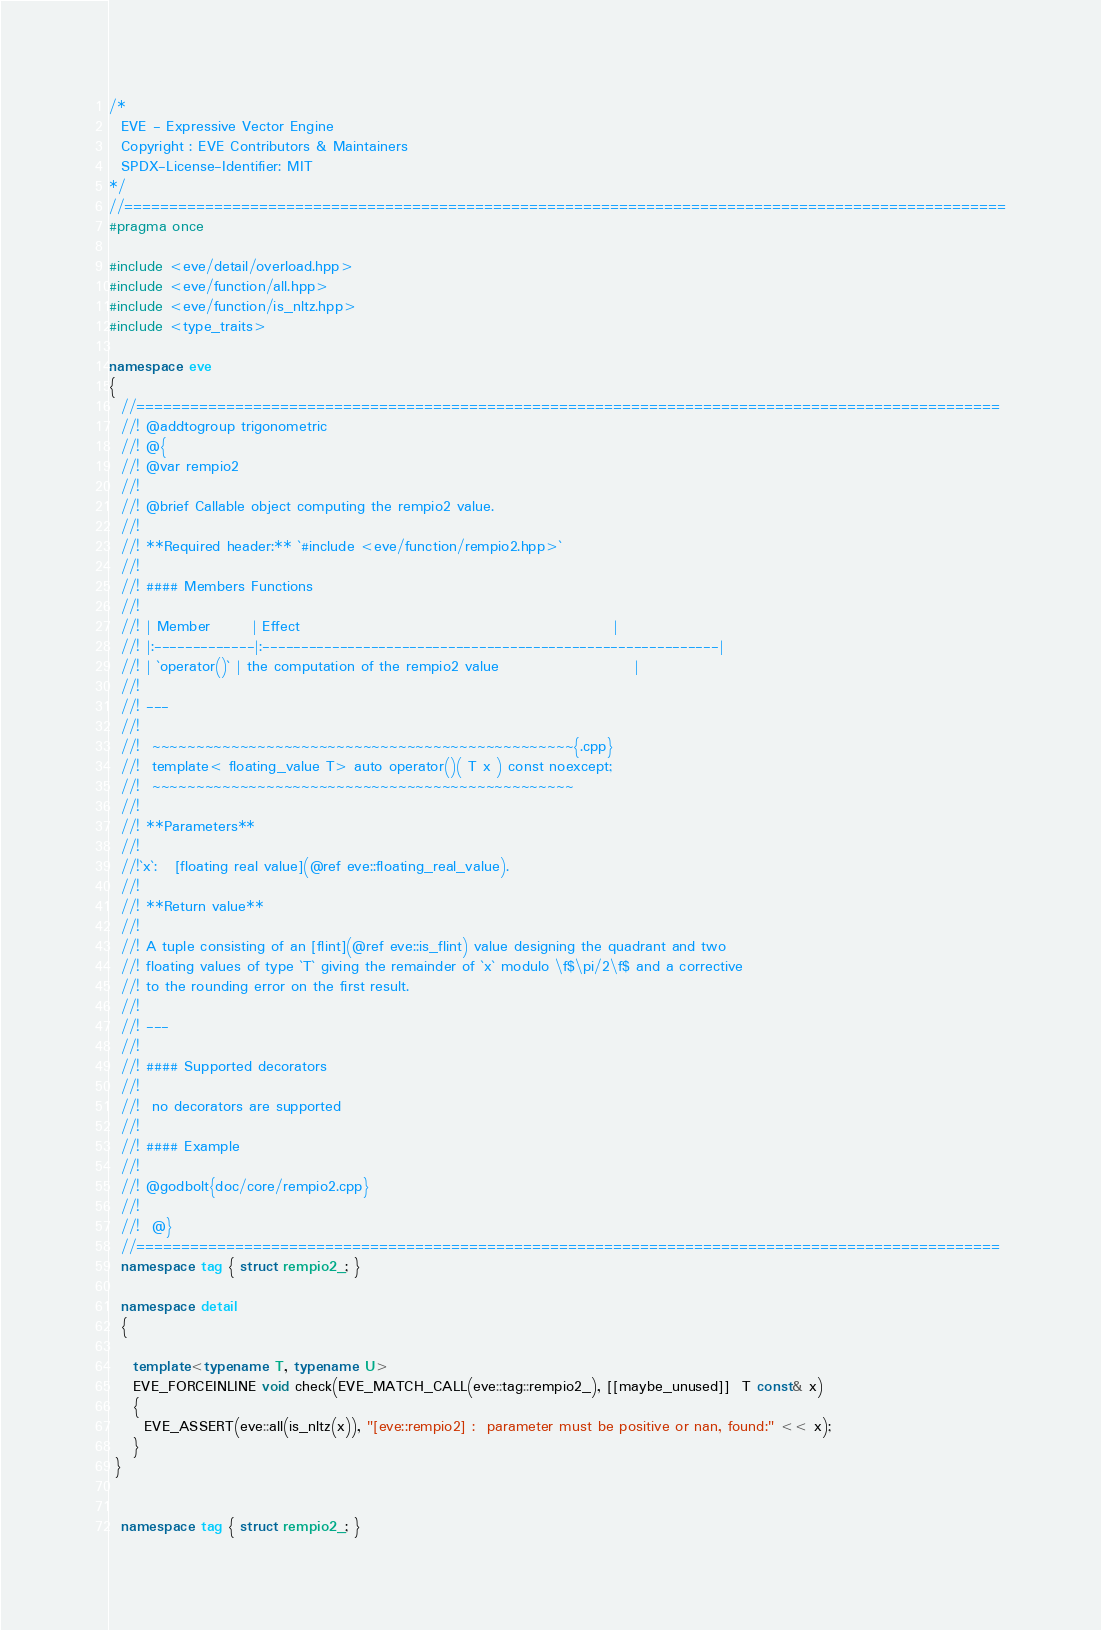Convert code to text. <code><loc_0><loc_0><loc_500><loc_500><_C++_>/*
  EVE - Expressive Vector Engine
  Copyright : EVE Contributors & Maintainers
  SPDX-License-Identifier: MIT
*/
//==================================================================================================
#pragma once

#include <eve/detail/overload.hpp>
#include <eve/function/all.hpp>
#include <eve/function/is_nltz.hpp>
#include <type_traits>

namespace eve
{
  //================================================================================================
  //! @addtogroup trigonometric
  //! @{
  //! @var rempio2
  //!
  //! @brief Callable object computing the rempio2 value.
  //!
  //! **Required header:** `#include <eve/function/rempio2.hpp>`
  //!
  //! #### Members Functions
  //!
  //! | Member       | Effect                                                     |
  //! |:-------------|:-----------------------------------------------------------|
  //! | `operator()` | the computation of the rempio2 value                       |
  //!
  //! ---
  //!
  //!  ~~~~~~~~~~~~~~~~~~~~~~~~~~~~~~~~~~~~~~~~~~~~~~~~{.cpp}
  //!  template< floating_value T> auto operator()( T x ) const noexcept;
  //!  ~~~~~~~~~~~~~~~~~~~~~~~~~~~~~~~~~~~~~~~~~~~~~~~~
  //!
  //! **Parameters**
  //!
  //!`x`:   [floating real value](@ref eve::floating_real_value).
  //!
  //! **Return value**
  //!
  //! A tuple consisting of an [flint](@ref eve::is_flint) value designing the quadrant and two
  //! floating values of type `T` giving the remainder of `x` modulo \f$\pi/2\f$ and a corrective
  //! to the rounding error on the first result.
  //!
  //! ---
  //!
  //! #### Supported decorators
  //!
  //!  no decorators are supported
  //!
  //! #### Example
  //!
  //! @godbolt{doc/core/rempio2.cpp}
  //!
  //!  @}
  //================================================================================================
  namespace tag { struct rempio2_; }

  namespace detail
  {

    template<typename T, typename U>
    EVE_FORCEINLINE void check(EVE_MATCH_CALL(eve::tag::rempio2_), [[maybe_unused]]  T const& x)
    {
      EVE_ASSERT(eve::all(is_nltz(x)), "[eve::rempio2] :  parameter must be positive or nan, found:" << x);
    }
 }


  namespace tag { struct rempio2_; }</code> 